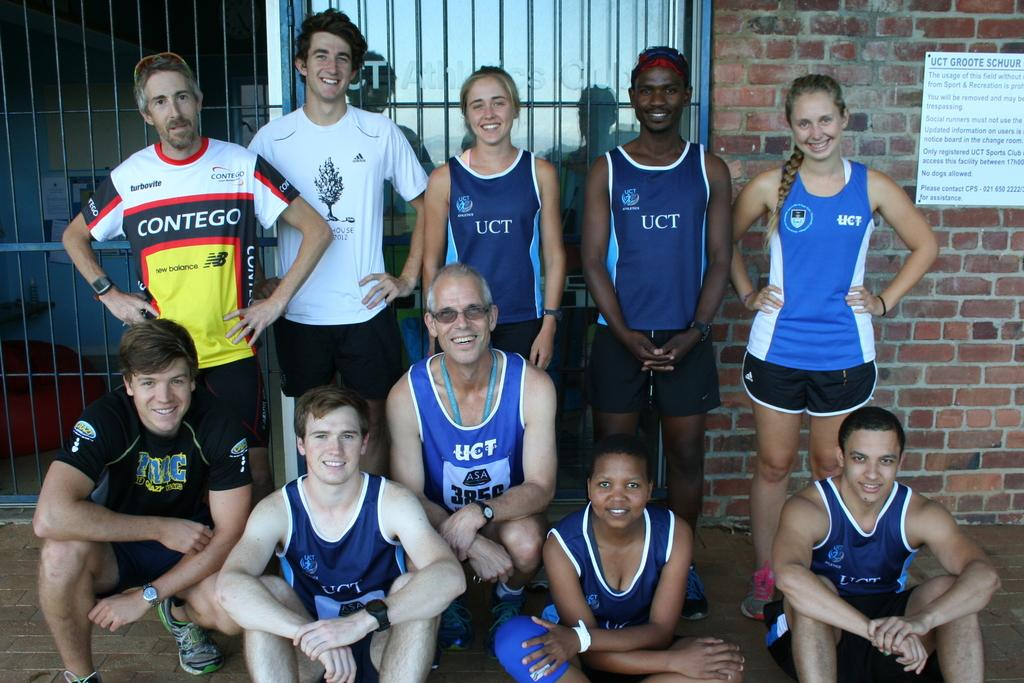Provide a one-sentence caption for the provided image. People in blue sports jerseys with UCT on them. 